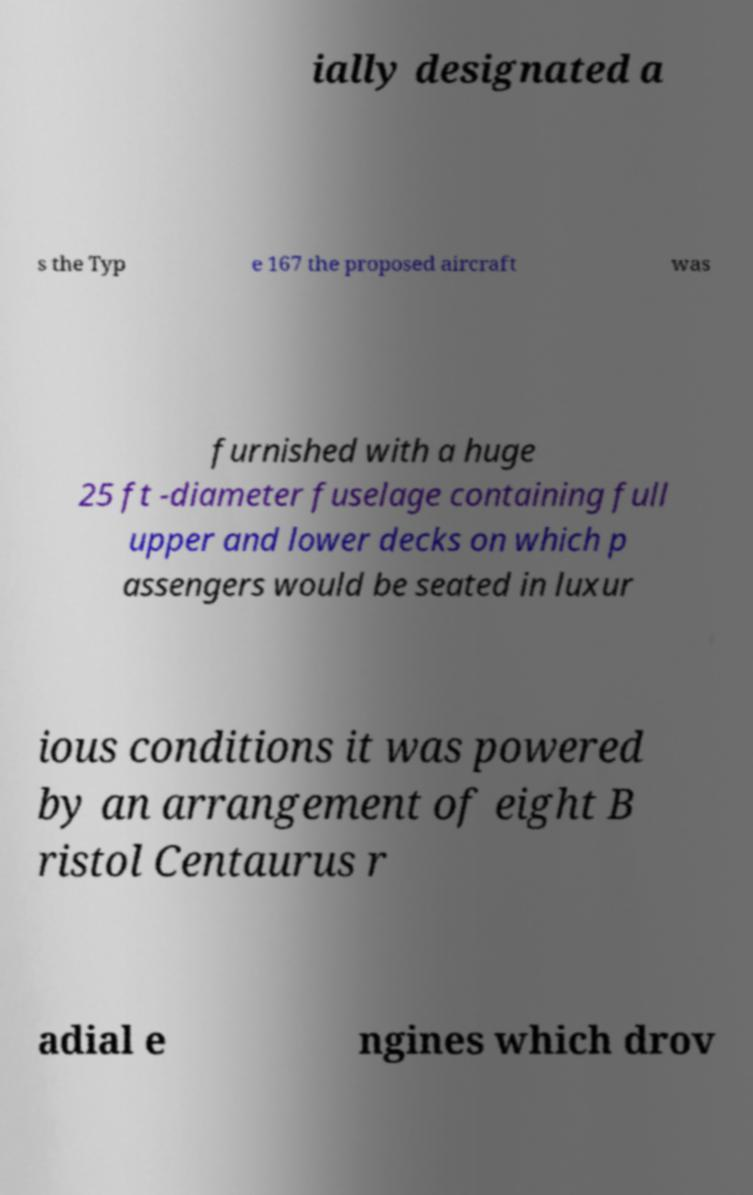Could you extract and type out the text from this image? ially designated a s the Typ e 167 the proposed aircraft was furnished with a huge 25 ft -diameter fuselage containing full upper and lower decks on which p assengers would be seated in luxur ious conditions it was powered by an arrangement of eight B ristol Centaurus r adial e ngines which drov 